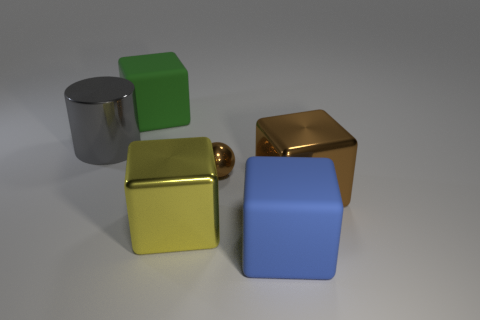Subtract all green blocks. How many blocks are left? 3 Subtract all balls. How many objects are left? 5 Add 3 rubber cubes. How many objects exist? 9 Subtract all brown cubes. How many cubes are left? 3 Subtract all purple balls. Subtract all red cylinders. How many balls are left? 1 Subtract all purple cylinders. How many red blocks are left? 0 Subtract all tiny metal spheres. Subtract all brown balls. How many objects are left? 4 Add 6 green rubber cubes. How many green rubber cubes are left? 7 Add 2 brown cylinders. How many brown cylinders exist? 2 Subtract 0 purple balls. How many objects are left? 6 